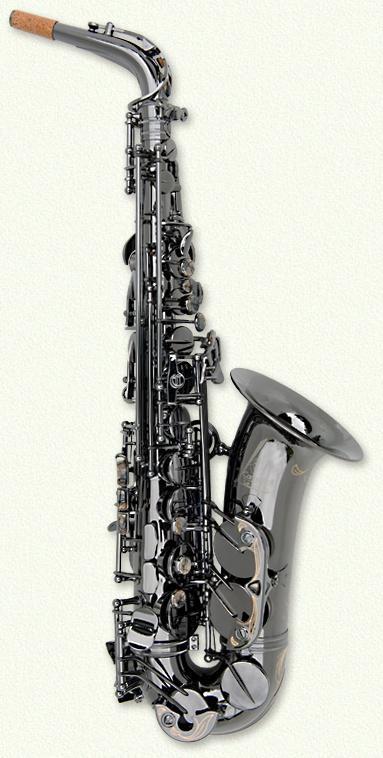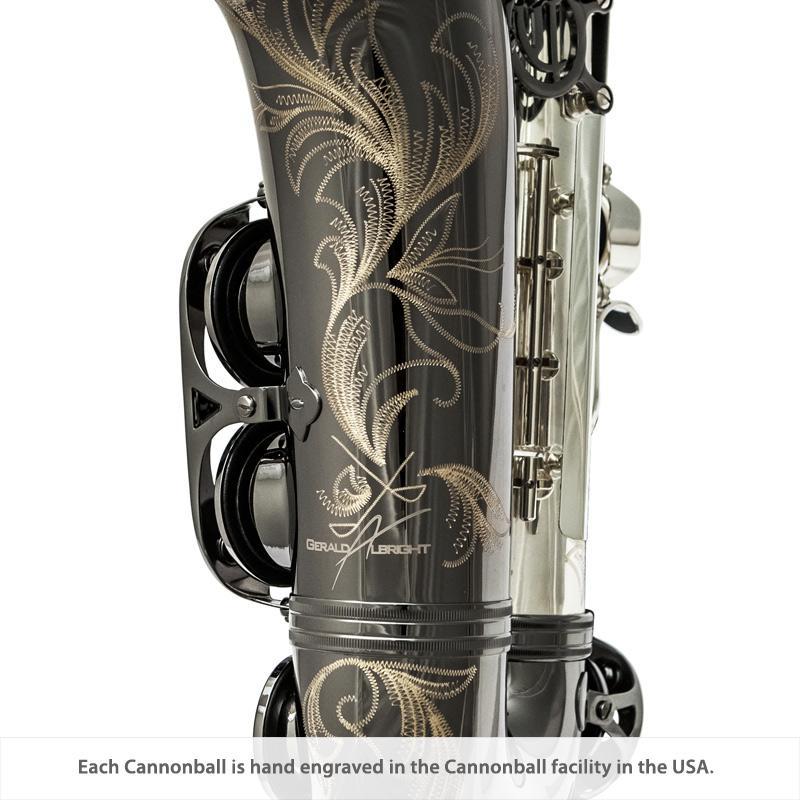The first image is the image on the left, the second image is the image on the right. Assess this claim about the two images: "The left image shows one saxophone displayed upright with its bell facing right, and the right image shows decorative etching embellishing the bell-end of a saxophone.". Correct or not? Answer yes or no. Yes. The first image is the image on the left, the second image is the image on the right. For the images displayed, is the sentence "The mouthpiece is visible in both images." factually correct? Answer yes or no. No. 